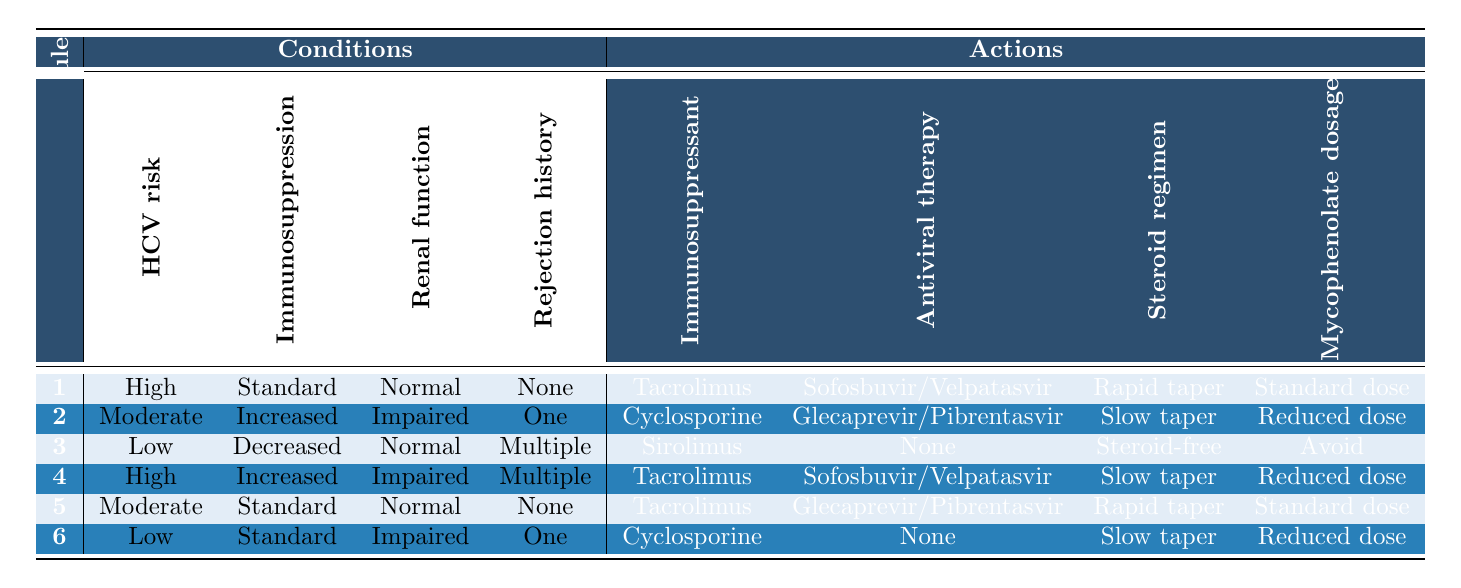What is the primary immunosuppressant recommended for patients with high HCV recurrence risk, standard immunosuppression, normal renal function, and no history of rejection? According to rule 1 in the table, the primary immunosuppressant for these specific conditions is Tacrolimus.
Answer: Tacrolimus Is there a different antiviral therapy suggested for patients with a moderate HCV recurrence risk and impaired renal function? Rule 2 indicates that for a moderate HCV recurrence risk and impaired renal function, the recommended antiviral therapy is Glecaprevir/Pibrentasvir. This is different from the antiviral treatment for high-risk patients (Sofosbuvir/Velpatasvir), confirming that the suggestion changes based on the conditions.
Answer: Yes, Glecaprevir/Pibrentasvir What is the common steroid regimen for patients with a low HCV recurrence risk and a history of multiple rejection episodes? Rule 3 shows that for patients with low HCV recurrence risk and multiple rejection episodes, the steroid regimen is Steroid-free.
Answer: Steroid-free For patients who are on high immunosuppression and have impaired renal function with multiple rejection episodes, what is the mycophenolate mofetil dosage recommended? From rule 4, the mycophenolate mofetil dosage for high immunosuppression, impaired renal function, and multiple rejection episodes is Reduced dose.
Answer: Reduced dose What are the actions taken for a patient with a low HCV recurrence risk, decreased immunosuppression, normal renal function, and multiple rejection episodes? Rule 3 outlines that for these conditions, the actions taken are to use Sirolimus as the immunosuppressant, no antiviral therapy, a Steroid-free regimen, and to Avoid mycophenolate mofetil.
Answer: Sirolimus, None, Steroid-free, Avoid If we consider all rules, how many different antiviral therapies are recommended when patients have normal renal function? In rule 1 and rule 5, the recommended antiviral therapies when the renal function is normal are Sofosbuvir/Velpatasvir and Glecaprevir/Pibrentasvir. Hence, there are two different antiviral therapies for patients with normal renal function.
Answer: 2 Is there any case in the table where a patient's steroid regimen is a rapid taper? Looking at rules 1 and 5, both have a rapid taper recommended under specific conditions. Hence, there are cases where a rapid taper is the steroid regimen.
Answer: Yes What is the primary immunosuppressant prescribed for patients with a moderate HCV recurrence risk and no previous rejection episodes? Rule 5 indicates that the immunosuppressant for patients with these conditions is Tacrolimus.
Answer: Tacrolimus 